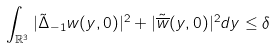<formula> <loc_0><loc_0><loc_500><loc_500>\int _ { \mathbb { R } ^ { 3 } } | \tilde { \Delta } _ { - 1 } w ( y , 0 ) | ^ { 2 } + | \tilde { \overline { w } } ( y , 0 ) | ^ { 2 } d y \leq \delta</formula> 